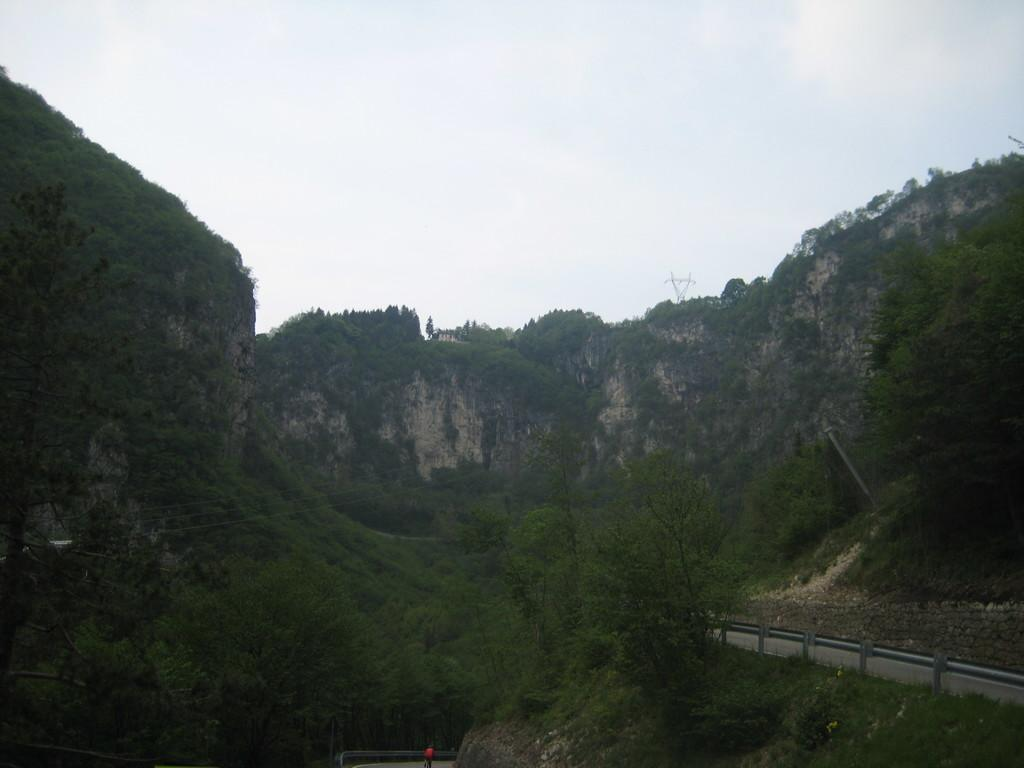What type of vegetation can be seen in the image? There are trees in the image. What geographical feature is present in the image? There is a hill in the image. What man-made structure is visible in the image? There is a wall in the image. What part of the natural environment is visible in the image? The sky is visible in the image. What type of brass instrument is being played on the stage in the image? There is no brass instrument or stage present in the image; it features trees, a hill, a wall, and the sky. What channel is the image taken from? The image is not taken from a channel; it is a still image. 